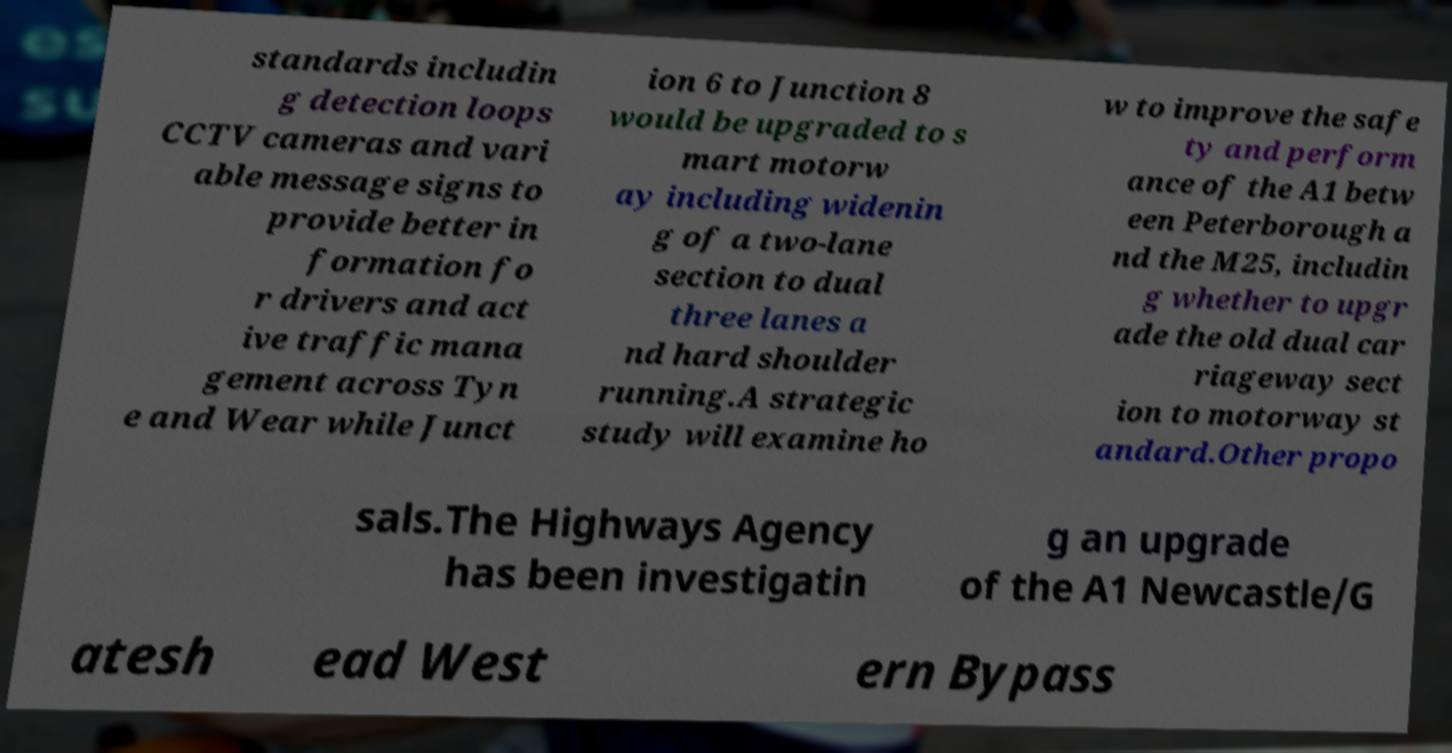Could you assist in decoding the text presented in this image and type it out clearly? standards includin g detection loops CCTV cameras and vari able message signs to provide better in formation fo r drivers and act ive traffic mana gement across Tyn e and Wear while Junct ion 6 to Junction 8 would be upgraded to s mart motorw ay including widenin g of a two-lane section to dual three lanes a nd hard shoulder running.A strategic study will examine ho w to improve the safe ty and perform ance of the A1 betw een Peterborough a nd the M25, includin g whether to upgr ade the old dual car riageway sect ion to motorway st andard.Other propo sals.The Highways Agency has been investigatin g an upgrade of the A1 Newcastle/G atesh ead West ern Bypass 